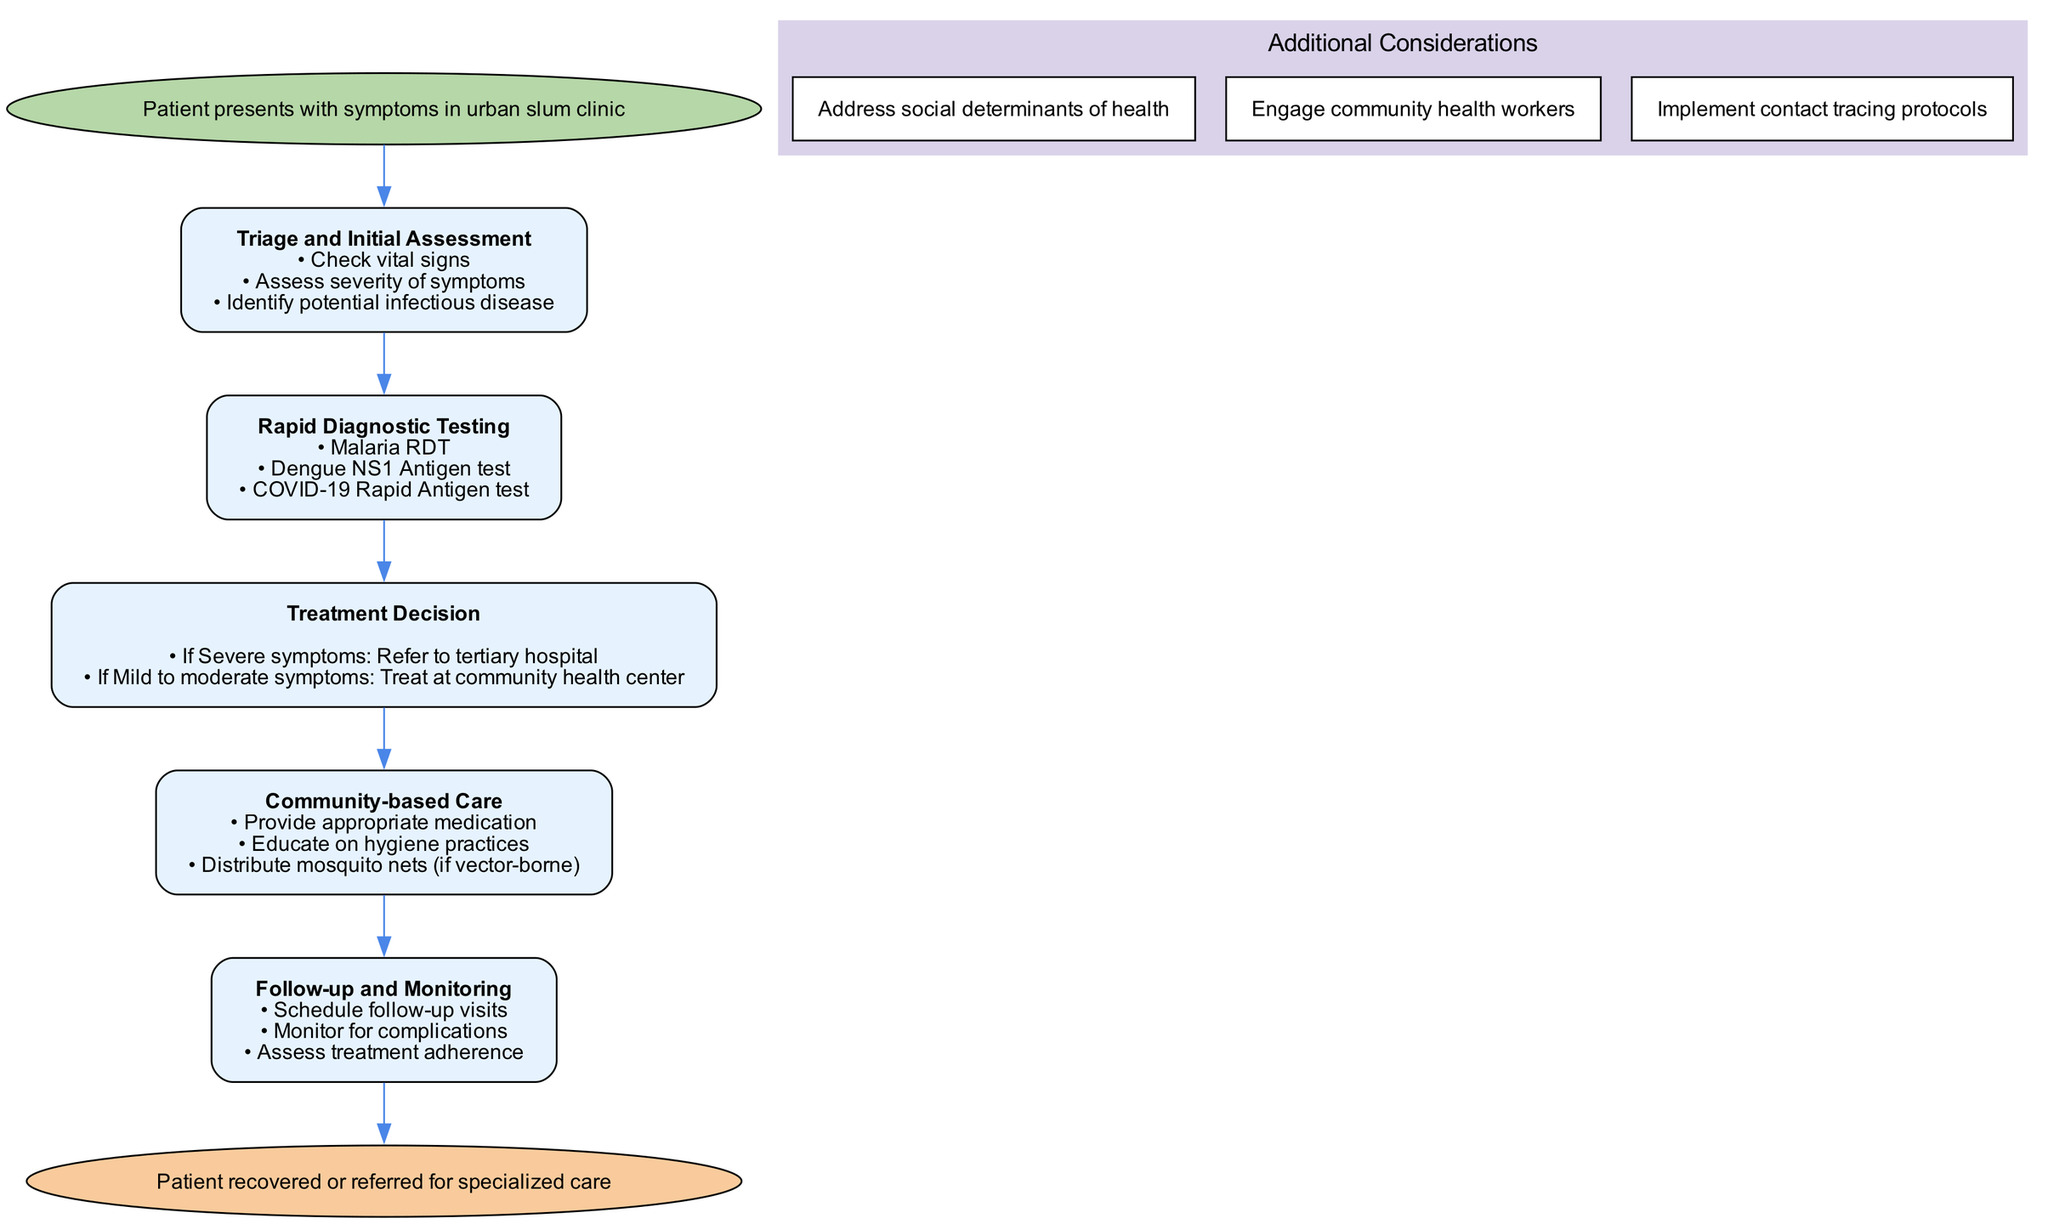What is the starting point of the clinical pathway? The starting point of the diagram is specified as "Patient presents with symptoms in urban slum clinic." This is identifiable at the top of the diagram, labeled as the starting node.
Answer: Patient presents with symptoms in urban slum clinic How many steps are there in the clinical pathway? The clinical pathway includes a total of five distinct steps, each represented as separate nodes after the initial starting point. These steps outline the process from triage to follow-up care.
Answer: 5 What is the first action listed in the Triage and Initial Assessment step? The first action outlined in the Triage and Initial Assessment step is "Check vital signs." This action is part of the bullet points listed under the first step in the pathway.
Answer: Check vital signs What happens when a patient presents with severe symptoms? If a patient presents with severe symptoms, the pathway indicates that the action taken is to "Refer to tertiary hospital." This is derived from the Treatment Decision step in the clinical pathway.
Answer: Refer to tertiary hospital What additional consideration addresses community engagement? The additional consideration that focuses on community engagement is "Engage community health workers." This is noted among the additional considerations at the bottom of the diagram.
Answer: Engage community health workers How is follow-up handled according to the clinical pathway? Follow-up is managed by scheduling follow-up visits, monitoring for complications, and assessing treatment adherence, as indicated in the Follow-up and Monitoring step of the pathway.
Answer: Schedule follow-up visits, monitor for complications, assess treatment adherence What type of diagnostic tests are available in the Rapid Diagnostic Testing step? The Rapid Diagnostic Testing step lists three diagnostic tests, which are "Malaria RDT," "Dengue NS1 Antigen test," and "COVID-19 Rapid Antigen test." These options are presented as bullet points within that step.
Answer: Malaria RDT, Dengue NS1 Antigen test, COVID-19 Rapid Antigen test What is the end point for the clinical pathway? The end point of the clinical pathway is articulated as "Patient recovered or referred for specialized care." This signifies the conclusion of the pathway following the treatment process.
Answer: Patient recovered or referred for specialized care 